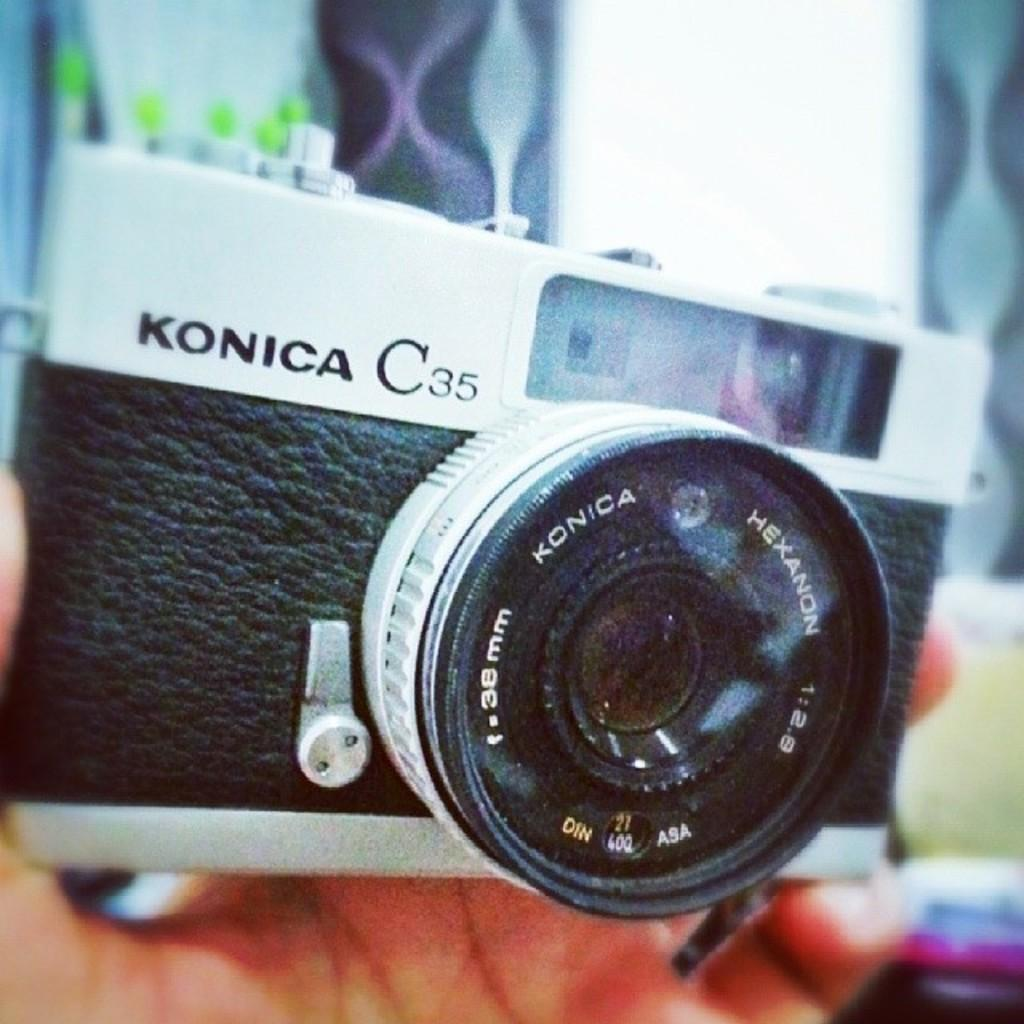What can be seen in the image? There is a person's hand in the image. What is the hand holding? The hand is holding a camera. Where is the camera located in the image? The camera is in the center of the image. What type of pollution is visible in the image? There is no pollution visible in the image; it only features a person's hand holding a camera. 